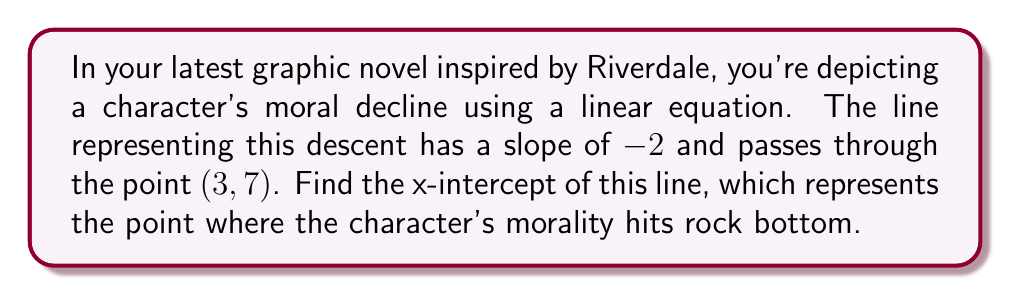Can you answer this question? Let's approach this step-by-step:

1) We know the slope-intercept form of a line is $y = mx + b$, where $m$ is the slope and $b$ is the y-intercept.

2) We're given that the slope $m = -2$, so our equation starts as:
   $y = -2x + b$

3) We also know that the line passes through the point (3, 7). Let's use this to find $b$:
   $7 = -2(3) + b$
   $7 = -6 + b$
   $b = 13$

4) Now we have our complete line equation:
   $y = -2x + 13$

5) To find the x-intercept, we need to find where $y = 0$:
   $0 = -2x + 13$

6) Solve for $x$:
   $2x = 13$
   $x = \frac{13}{2} = 6.5$

Therefore, the x-intercept is at $x = 6.5$.
Answer: $\frac{13}{2}$ or $6.5$ 